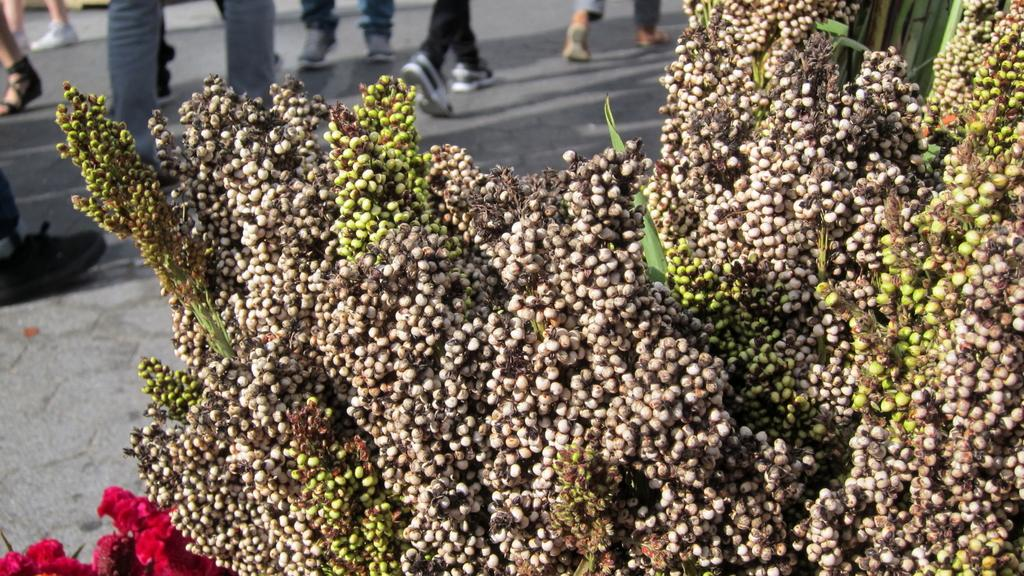Where was the picture taken? The picture was clicked outside. What can be seen in the foreground of the image? There is a tree and flowers in the foreground of the image. What is happening in the background of the image? There is a group of people in the background of the image. What are the people in the background doing? The group of people is walking on the ground. What is the color of the downtown area in the image? There is no downtown area present in the image. 